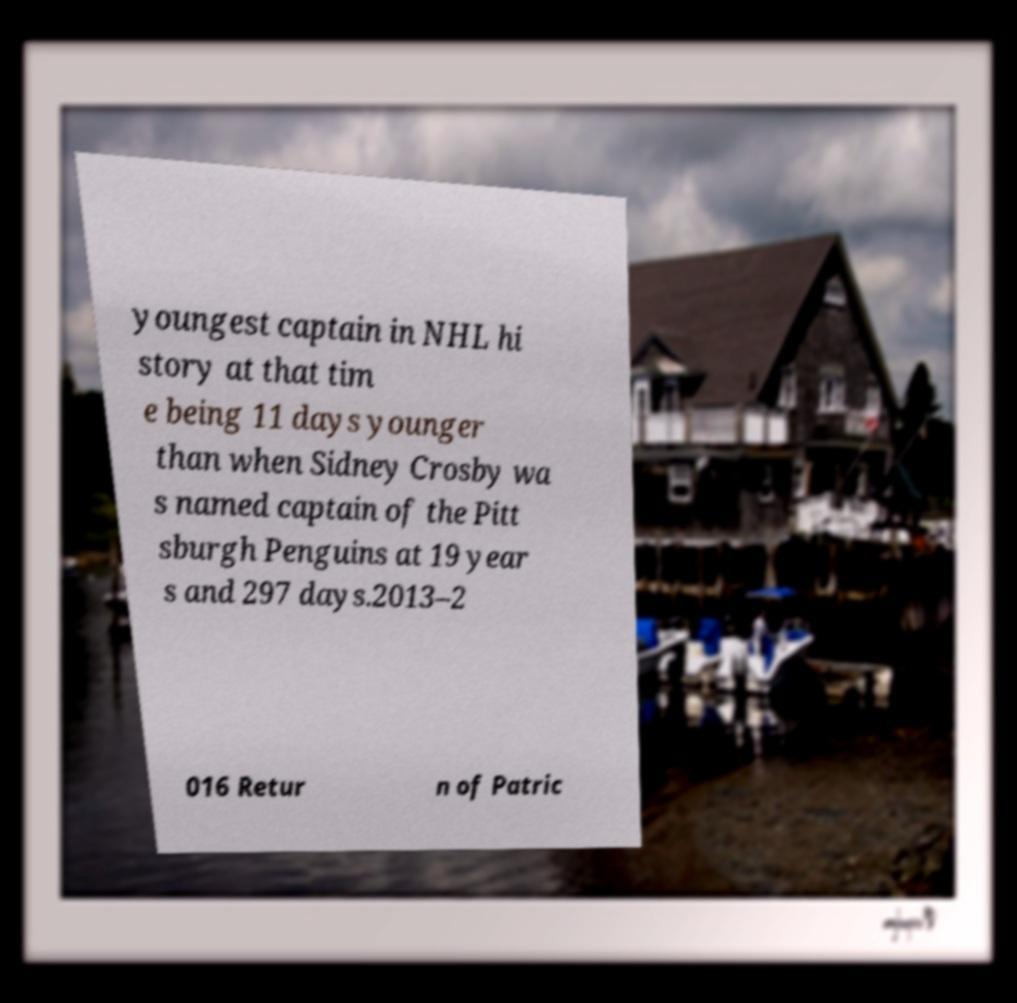For documentation purposes, I need the text within this image transcribed. Could you provide that? youngest captain in NHL hi story at that tim e being 11 days younger than when Sidney Crosby wa s named captain of the Pitt sburgh Penguins at 19 year s and 297 days.2013–2 016 Retur n of Patric 